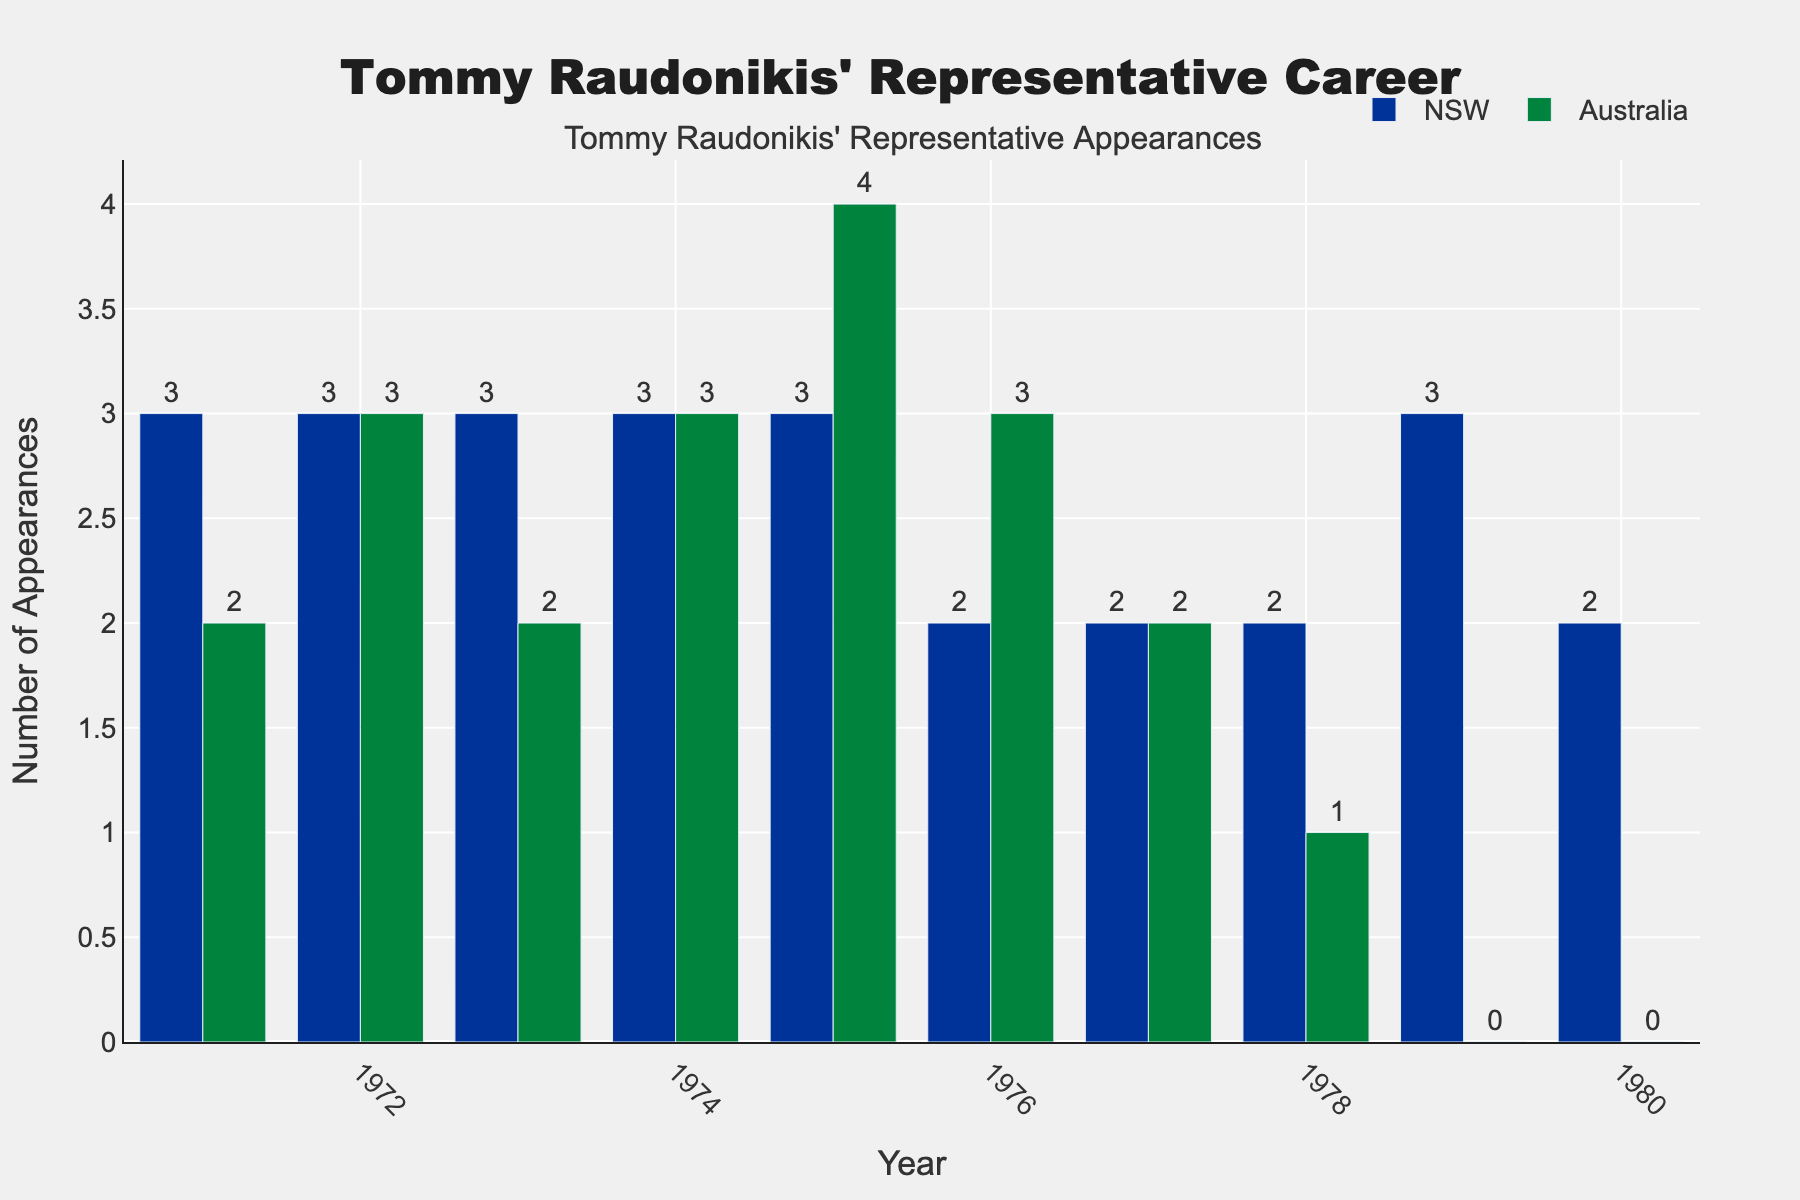Which year had the highest number of representative appearances for Australia? Looking at the bars for Australia, the highest bar corresponds to 1975, where Tommy Raudonikis made 4 appearances.
Answer: 1975 In which year did Tommy Raudonikis have an equal number of appearances for both NSW and Australia? Inspecting the bars, both NSW and Australia have equal heights in 1972 and 1974, each year having 3 appearances for each team.
Answer: 1972 and 1974 What is the total number of appearances for NSW from 1971 to 1980? Add the number of appearances for each year: 3 + 3 + 3 + 3 + 3 + 2 + 2 + 2 + 3 + 2 = 26
Answer: 26 How did Tommy Raudonikis' appearances for NSW in 1979 compare to his appearances for Australia in the same year? In 1979, the height of the NSW bar is 3, while the Australia bar is 0, indicating he did not appear for Australia that year.
Answer: 3 greater What is the average number of appearances for Australia from 1971 to 1980? Total appearances for Australia is 2+3+2+3+4+3+2+1+0+0 = 20. There are 10 data points, so the average = 20/10 = 2.
Answer: 2 In which year did Tommy Raudonikis have the fewest appearances for Australia, and how many were there? Looking at the bars, the lowest heights for Australia bars are in 1978, 1979, and 1980, with 1, 0, and 0 appearances respectively. The fewest appearances (0) happened in 1979 and 1980.
Answer: 1979 and 1980, 0 Which year had the maximum difference between Tommy Raudonikis' appearances for NSW and Australia? By calculating the difference for each year: 1 in 1971, 0 in 1972, 1 in 1973, 0 in 1974, 1 in 1975, 1 in 1976, 0 in 1977, 1 in 1978, 3 in 1979, 2 in 1980. The maximum difference is 3 in 1979.
Answer: 1979 How many more appearances did Tommy Raudonikis make for NSW than Australia in 1978? In 1978, appearances for NSW = 2 and for Australia = 1. The difference is 2 - 1 = 1.
Answer: 1 Visualize the data: In which year are the heights of the NSW and Australia bars most similar? The heights of the NSW and Australia bars are most similar in the years where their differences are 0: 1972, 1974, 1977.
Answer: 1972, 1974, 1977 